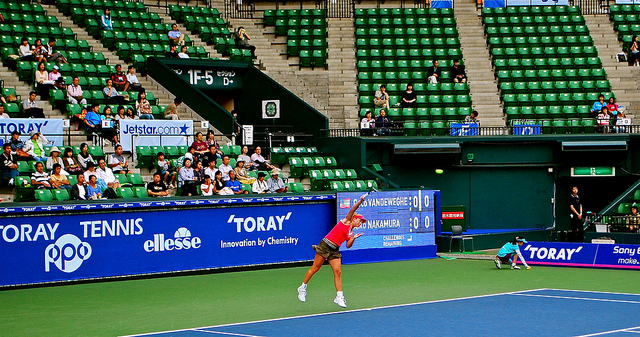Read and extract the text from this image. TORAY Innovation by Chemistry ellesse TENNIS TORAY ppo make. Sony TORAY 0 0 0 0 NAKAHURA VANDEWAGHE TORAY Jetstar.com D 1F-5 